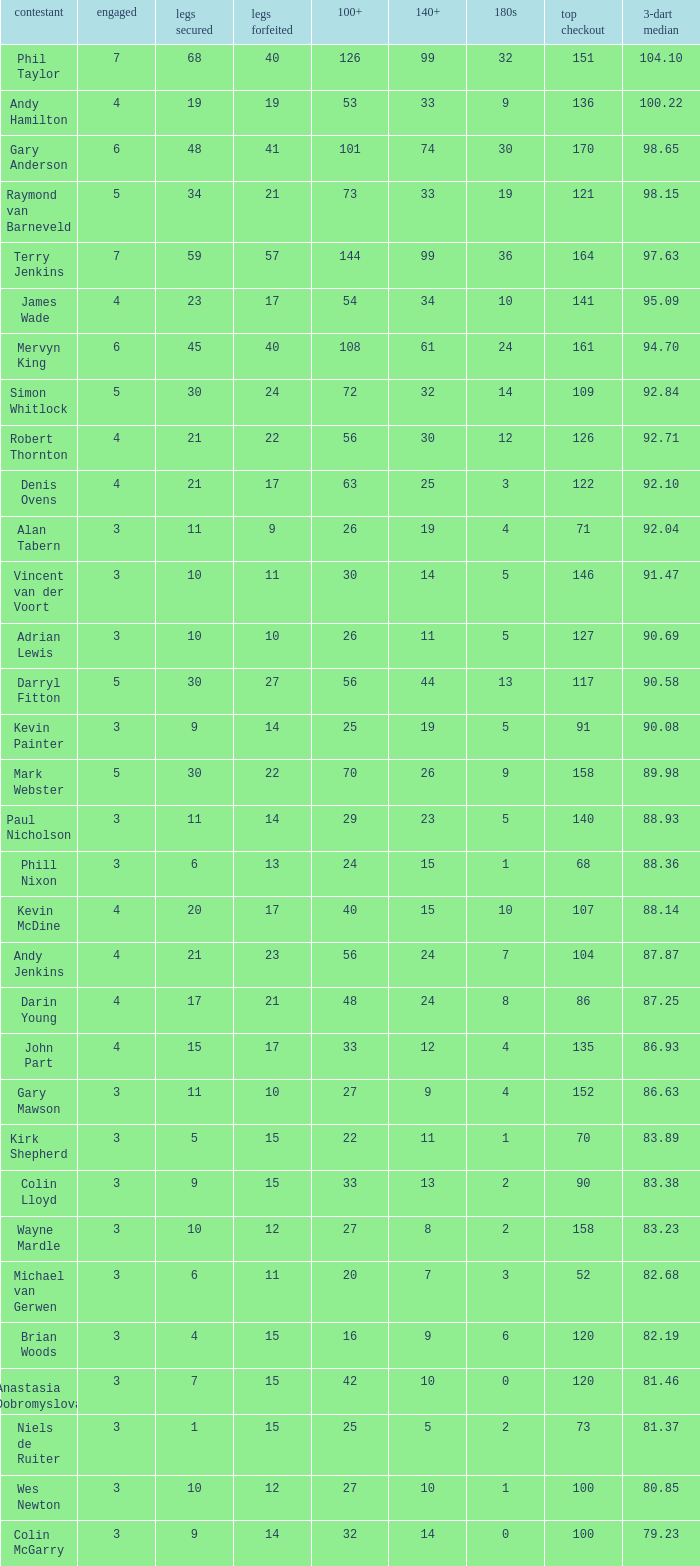What is the highest Legs Lost with a 180s larger than 1, a 100+ of 53, and played is smaller than 4? None. 